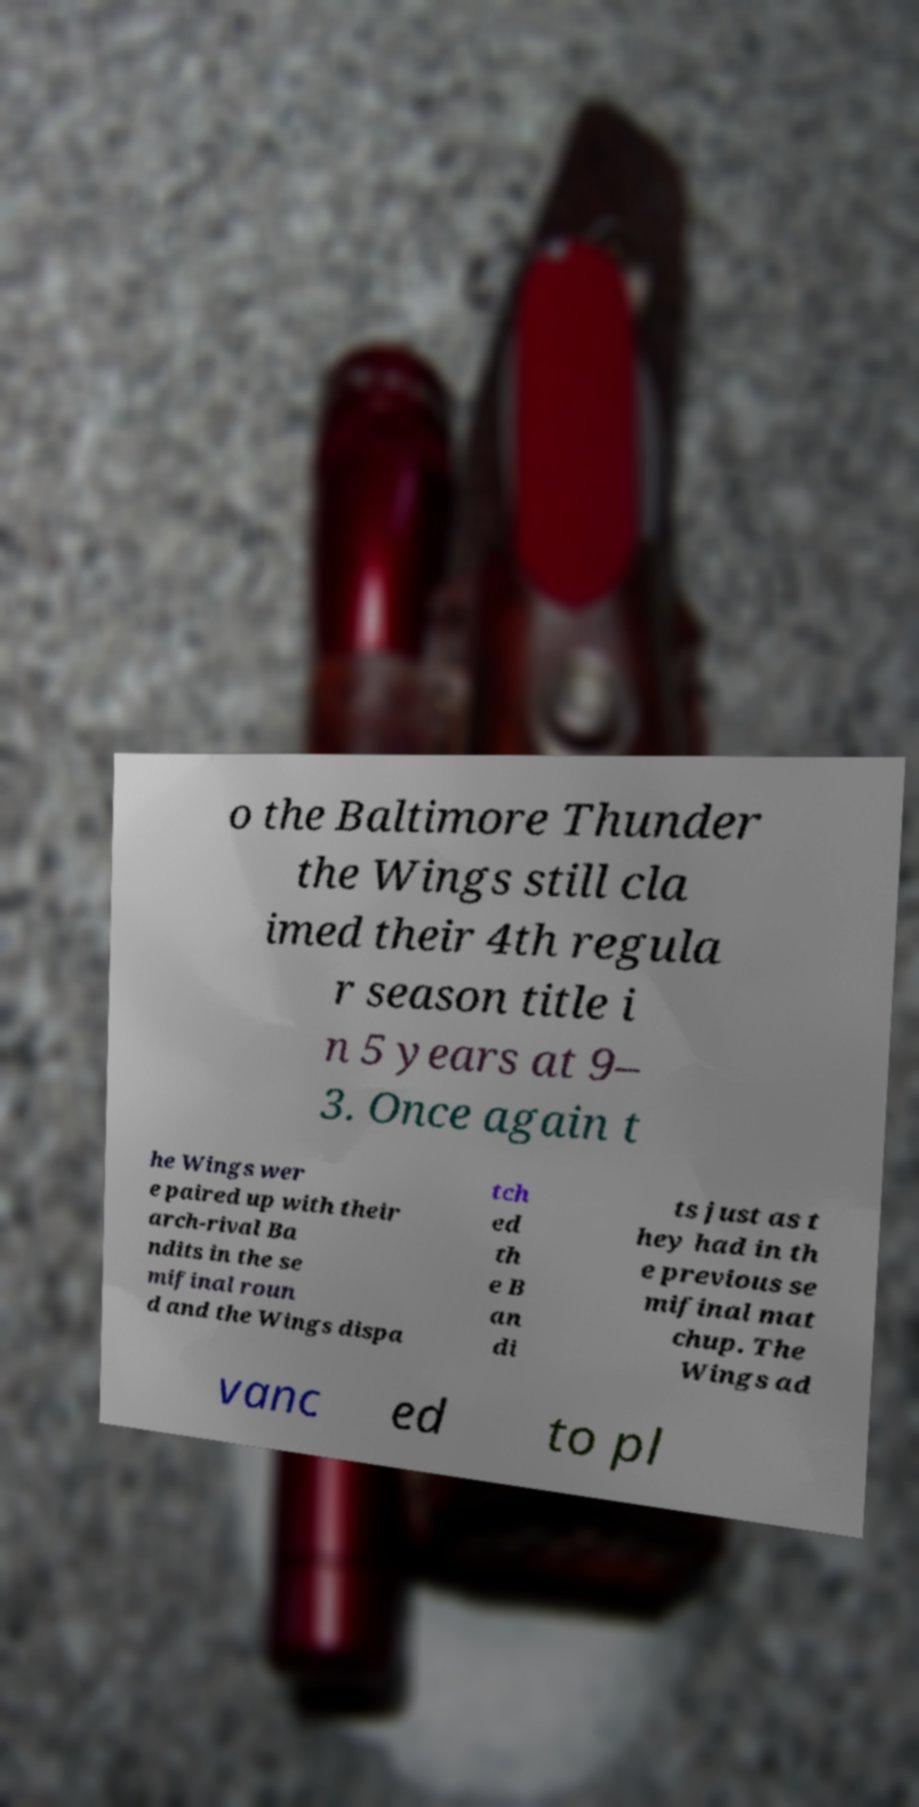There's text embedded in this image that I need extracted. Can you transcribe it verbatim? o the Baltimore Thunder the Wings still cla imed their 4th regula r season title i n 5 years at 9– 3. Once again t he Wings wer e paired up with their arch-rival Ba ndits in the se mifinal roun d and the Wings dispa tch ed th e B an di ts just as t hey had in th e previous se mifinal mat chup. The Wings ad vanc ed to pl 